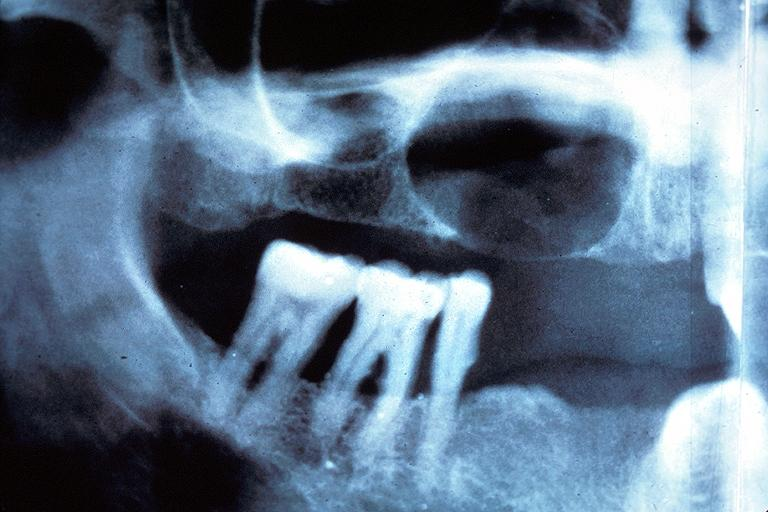does this image show residual cyst?
Answer the question using a single word or phrase. Yes 